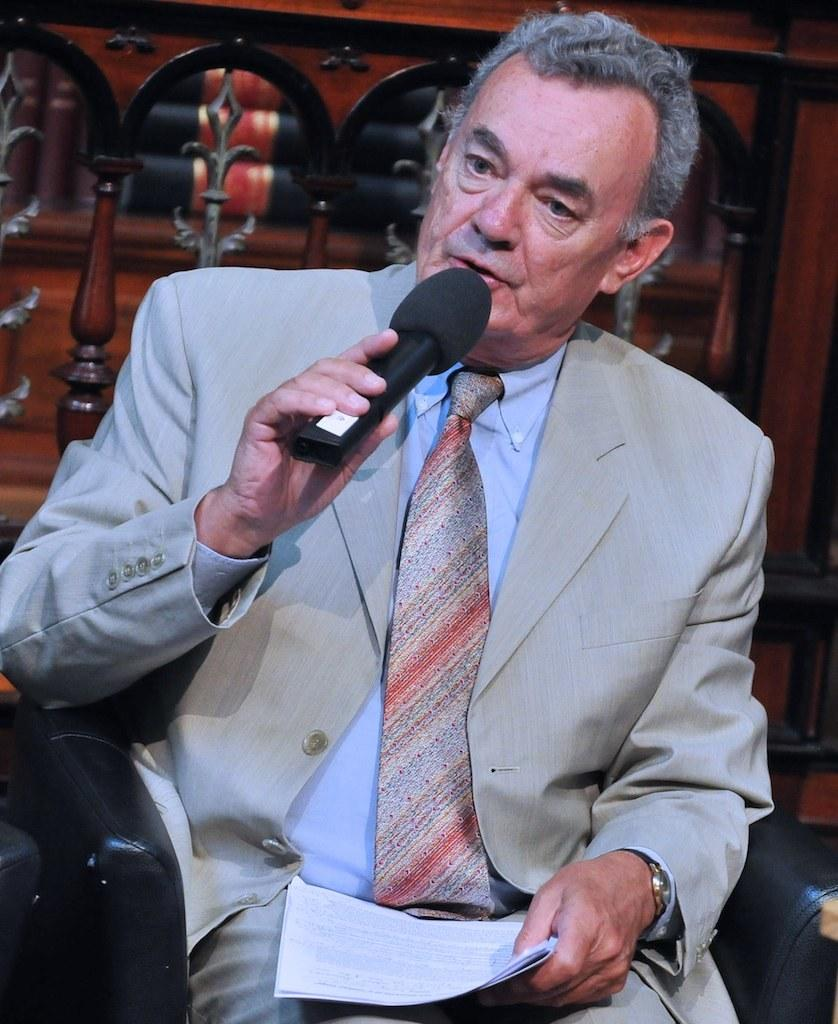What is the man in the image doing? The man is sitting on a sofa. What is the man holding in the image? The man is holding a microphone and a paper. What accessory is the man wearing in the image? The man is wearing a watch. What type of peace symbol can be seen in the image? There is no peace symbol present in the image. What color is the note that the man is holding in the image? The man is holding a paper, not a note, and the color of the paper cannot be determined from the image. 